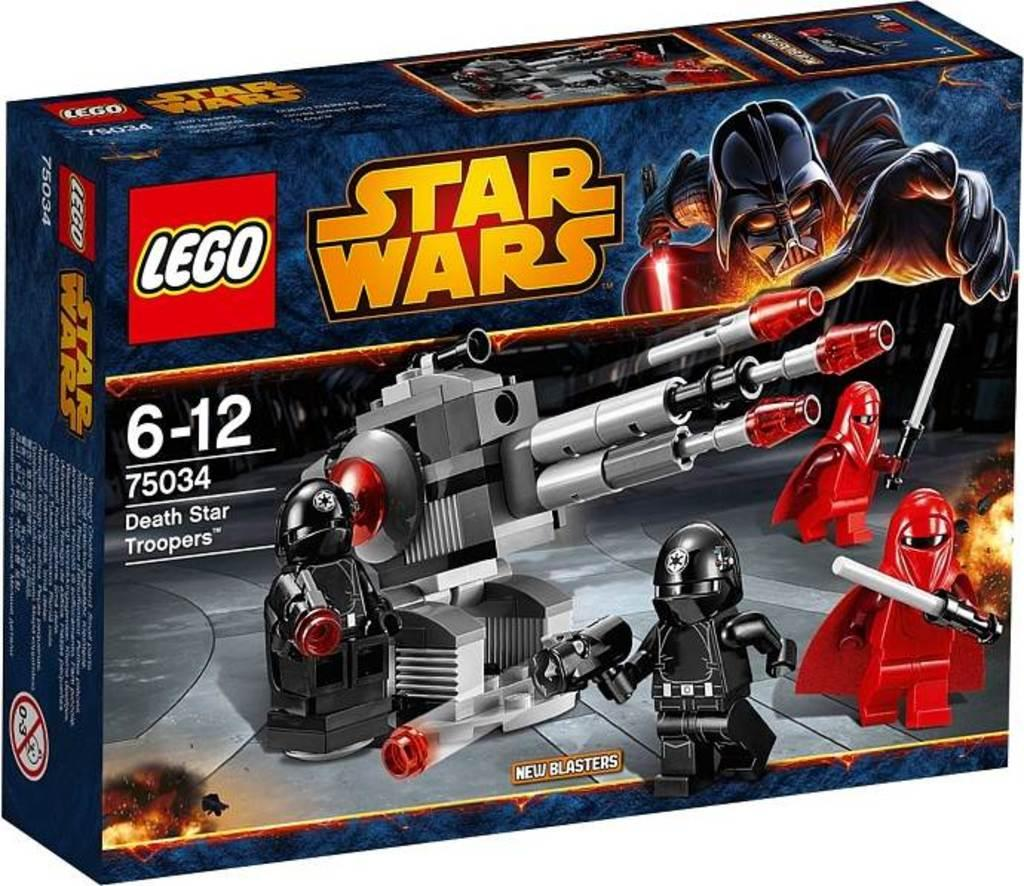<image>
Provide a brief description of the given image. A Lego Star Wars play set number 75034. 